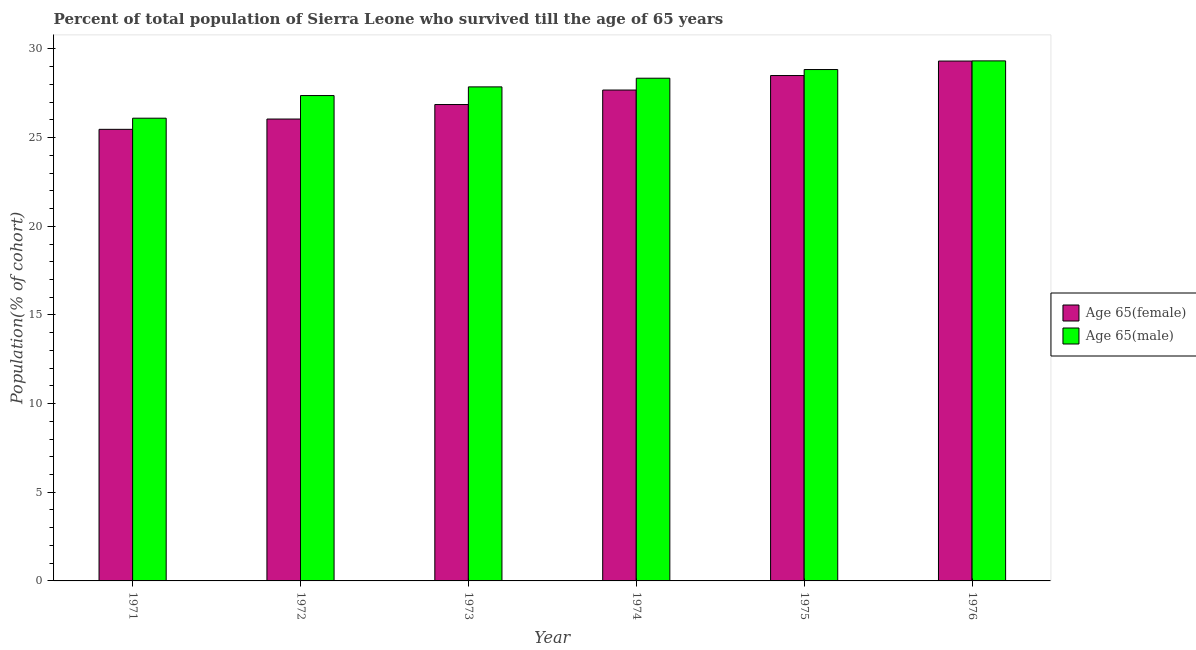Are the number of bars on each tick of the X-axis equal?
Keep it short and to the point. Yes. How many bars are there on the 6th tick from the left?
Provide a succinct answer. 2. What is the label of the 3rd group of bars from the left?
Make the answer very short. 1973. In how many cases, is the number of bars for a given year not equal to the number of legend labels?
Your answer should be very brief. 0. What is the percentage of male population who survived till age of 65 in 1976?
Make the answer very short. 29.33. Across all years, what is the maximum percentage of female population who survived till age of 65?
Ensure brevity in your answer.  29.32. Across all years, what is the minimum percentage of male population who survived till age of 65?
Ensure brevity in your answer.  26.09. In which year was the percentage of female population who survived till age of 65 maximum?
Offer a very short reply. 1976. What is the total percentage of female population who survived till age of 65 in the graph?
Ensure brevity in your answer.  163.88. What is the difference between the percentage of male population who survived till age of 65 in 1972 and that in 1976?
Give a very brief answer. -1.96. What is the difference between the percentage of female population who survived till age of 65 in 1976 and the percentage of male population who survived till age of 65 in 1971?
Keep it short and to the point. 3.85. What is the average percentage of male population who survived till age of 65 per year?
Give a very brief answer. 27.97. In the year 1971, what is the difference between the percentage of male population who survived till age of 65 and percentage of female population who survived till age of 65?
Provide a succinct answer. 0. What is the ratio of the percentage of female population who survived till age of 65 in 1972 to that in 1973?
Provide a succinct answer. 0.97. Is the percentage of female population who survived till age of 65 in 1973 less than that in 1975?
Provide a succinct answer. Yes. What is the difference between the highest and the second highest percentage of male population who survived till age of 65?
Your answer should be compact. 0.49. What is the difference between the highest and the lowest percentage of female population who survived till age of 65?
Make the answer very short. 3.85. In how many years, is the percentage of female population who survived till age of 65 greater than the average percentage of female population who survived till age of 65 taken over all years?
Your answer should be compact. 3. What does the 1st bar from the left in 1971 represents?
Provide a succinct answer. Age 65(female). What does the 2nd bar from the right in 1971 represents?
Offer a terse response. Age 65(female). How many years are there in the graph?
Provide a succinct answer. 6. What is the difference between two consecutive major ticks on the Y-axis?
Offer a very short reply. 5. Are the values on the major ticks of Y-axis written in scientific E-notation?
Your answer should be very brief. No. Does the graph contain grids?
Offer a terse response. No. How are the legend labels stacked?
Give a very brief answer. Vertical. What is the title of the graph?
Give a very brief answer. Percent of total population of Sierra Leone who survived till the age of 65 years. What is the label or title of the X-axis?
Provide a short and direct response. Year. What is the label or title of the Y-axis?
Keep it short and to the point. Population(% of cohort). What is the Population(% of cohort) of Age 65(female) in 1971?
Your response must be concise. 25.47. What is the Population(% of cohort) in Age 65(male) in 1971?
Offer a very short reply. 26.09. What is the Population(% of cohort) of Age 65(female) in 1972?
Your answer should be compact. 26.05. What is the Population(% of cohort) of Age 65(male) in 1972?
Your answer should be compact. 27.37. What is the Population(% of cohort) of Age 65(female) in 1973?
Ensure brevity in your answer.  26.86. What is the Population(% of cohort) in Age 65(male) in 1973?
Offer a terse response. 27.86. What is the Population(% of cohort) of Age 65(female) in 1974?
Your response must be concise. 27.68. What is the Population(% of cohort) in Age 65(male) in 1974?
Ensure brevity in your answer.  28.35. What is the Population(% of cohort) of Age 65(female) in 1975?
Make the answer very short. 28.5. What is the Population(% of cohort) in Age 65(male) in 1975?
Make the answer very short. 28.84. What is the Population(% of cohort) in Age 65(female) in 1976?
Your answer should be very brief. 29.32. What is the Population(% of cohort) of Age 65(male) in 1976?
Offer a very short reply. 29.33. Across all years, what is the maximum Population(% of cohort) of Age 65(female)?
Give a very brief answer. 29.32. Across all years, what is the maximum Population(% of cohort) of Age 65(male)?
Provide a short and direct response. 29.33. Across all years, what is the minimum Population(% of cohort) of Age 65(female)?
Keep it short and to the point. 25.47. Across all years, what is the minimum Population(% of cohort) of Age 65(male)?
Make the answer very short. 26.09. What is the total Population(% of cohort) of Age 65(female) in the graph?
Provide a short and direct response. 163.88. What is the total Population(% of cohort) in Age 65(male) in the graph?
Offer a terse response. 167.84. What is the difference between the Population(% of cohort) of Age 65(female) in 1971 and that in 1972?
Your answer should be compact. -0.58. What is the difference between the Population(% of cohort) in Age 65(male) in 1971 and that in 1972?
Your response must be concise. -1.28. What is the difference between the Population(% of cohort) in Age 65(female) in 1971 and that in 1973?
Ensure brevity in your answer.  -1.4. What is the difference between the Population(% of cohort) of Age 65(male) in 1971 and that in 1973?
Make the answer very short. -1.77. What is the difference between the Population(% of cohort) in Age 65(female) in 1971 and that in 1974?
Offer a terse response. -2.22. What is the difference between the Population(% of cohort) of Age 65(male) in 1971 and that in 1974?
Ensure brevity in your answer.  -2.25. What is the difference between the Population(% of cohort) of Age 65(female) in 1971 and that in 1975?
Your response must be concise. -3.03. What is the difference between the Population(% of cohort) in Age 65(male) in 1971 and that in 1975?
Your response must be concise. -2.74. What is the difference between the Population(% of cohort) of Age 65(female) in 1971 and that in 1976?
Make the answer very short. -3.85. What is the difference between the Population(% of cohort) in Age 65(male) in 1971 and that in 1976?
Give a very brief answer. -3.23. What is the difference between the Population(% of cohort) in Age 65(female) in 1972 and that in 1973?
Your answer should be very brief. -0.82. What is the difference between the Population(% of cohort) in Age 65(male) in 1972 and that in 1973?
Give a very brief answer. -0.49. What is the difference between the Population(% of cohort) in Age 65(female) in 1972 and that in 1974?
Make the answer very short. -1.64. What is the difference between the Population(% of cohort) of Age 65(male) in 1972 and that in 1974?
Your answer should be very brief. -0.98. What is the difference between the Population(% of cohort) of Age 65(female) in 1972 and that in 1975?
Offer a very short reply. -2.45. What is the difference between the Population(% of cohort) in Age 65(male) in 1972 and that in 1975?
Your response must be concise. -1.47. What is the difference between the Population(% of cohort) in Age 65(female) in 1972 and that in 1976?
Your answer should be very brief. -3.27. What is the difference between the Population(% of cohort) of Age 65(male) in 1972 and that in 1976?
Your answer should be compact. -1.96. What is the difference between the Population(% of cohort) in Age 65(female) in 1973 and that in 1974?
Your answer should be compact. -0.82. What is the difference between the Population(% of cohort) in Age 65(male) in 1973 and that in 1974?
Give a very brief answer. -0.49. What is the difference between the Population(% of cohort) of Age 65(female) in 1973 and that in 1975?
Your answer should be very brief. -1.64. What is the difference between the Population(% of cohort) of Age 65(male) in 1973 and that in 1975?
Offer a terse response. -0.98. What is the difference between the Population(% of cohort) in Age 65(female) in 1973 and that in 1976?
Keep it short and to the point. -2.45. What is the difference between the Population(% of cohort) of Age 65(male) in 1973 and that in 1976?
Make the answer very short. -1.47. What is the difference between the Population(% of cohort) in Age 65(female) in 1974 and that in 1975?
Your answer should be compact. -0.82. What is the difference between the Population(% of cohort) in Age 65(male) in 1974 and that in 1975?
Make the answer very short. -0.49. What is the difference between the Population(% of cohort) in Age 65(female) in 1974 and that in 1976?
Your answer should be compact. -1.64. What is the difference between the Population(% of cohort) in Age 65(male) in 1974 and that in 1976?
Offer a terse response. -0.98. What is the difference between the Population(% of cohort) of Age 65(female) in 1975 and that in 1976?
Provide a succinct answer. -0.82. What is the difference between the Population(% of cohort) in Age 65(male) in 1975 and that in 1976?
Your answer should be compact. -0.49. What is the difference between the Population(% of cohort) in Age 65(female) in 1971 and the Population(% of cohort) in Age 65(male) in 1972?
Offer a very short reply. -1.9. What is the difference between the Population(% of cohort) in Age 65(female) in 1971 and the Population(% of cohort) in Age 65(male) in 1973?
Provide a succinct answer. -2.39. What is the difference between the Population(% of cohort) in Age 65(female) in 1971 and the Population(% of cohort) in Age 65(male) in 1974?
Your answer should be compact. -2.88. What is the difference between the Population(% of cohort) in Age 65(female) in 1971 and the Population(% of cohort) in Age 65(male) in 1975?
Provide a succinct answer. -3.37. What is the difference between the Population(% of cohort) of Age 65(female) in 1971 and the Population(% of cohort) of Age 65(male) in 1976?
Make the answer very short. -3.86. What is the difference between the Population(% of cohort) in Age 65(female) in 1972 and the Population(% of cohort) in Age 65(male) in 1973?
Ensure brevity in your answer.  -1.81. What is the difference between the Population(% of cohort) of Age 65(female) in 1972 and the Population(% of cohort) of Age 65(male) in 1974?
Provide a succinct answer. -2.3. What is the difference between the Population(% of cohort) of Age 65(female) in 1972 and the Population(% of cohort) of Age 65(male) in 1975?
Give a very brief answer. -2.79. What is the difference between the Population(% of cohort) of Age 65(female) in 1972 and the Population(% of cohort) of Age 65(male) in 1976?
Offer a terse response. -3.28. What is the difference between the Population(% of cohort) in Age 65(female) in 1973 and the Population(% of cohort) in Age 65(male) in 1974?
Provide a succinct answer. -1.48. What is the difference between the Population(% of cohort) of Age 65(female) in 1973 and the Population(% of cohort) of Age 65(male) in 1975?
Provide a short and direct response. -1.97. What is the difference between the Population(% of cohort) in Age 65(female) in 1973 and the Population(% of cohort) in Age 65(male) in 1976?
Provide a succinct answer. -2.46. What is the difference between the Population(% of cohort) in Age 65(female) in 1974 and the Population(% of cohort) in Age 65(male) in 1975?
Make the answer very short. -1.16. What is the difference between the Population(% of cohort) in Age 65(female) in 1974 and the Population(% of cohort) in Age 65(male) in 1976?
Provide a succinct answer. -1.64. What is the difference between the Population(% of cohort) of Age 65(female) in 1975 and the Population(% of cohort) of Age 65(male) in 1976?
Offer a terse response. -0.83. What is the average Population(% of cohort) of Age 65(female) per year?
Your answer should be compact. 27.31. What is the average Population(% of cohort) of Age 65(male) per year?
Your answer should be compact. 27.97. In the year 1971, what is the difference between the Population(% of cohort) in Age 65(female) and Population(% of cohort) in Age 65(male)?
Your answer should be compact. -0.63. In the year 1972, what is the difference between the Population(% of cohort) of Age 65(female) and Population(% of cohort) of Age 65(male)?
Your answer should be compact. -1.32. In the year 1973, what is the difference between the Population(% of cohort) of Age 65(female) and Population(% of cohort) of Age 65(male)?
Make the answer very short. -1. In the year 1974, what is the difference between the Population(% of cohort) of Age 65(female) and Population(% of cohort) of Age 65(male)?
Keep it short and to the point. -0.67. In the year 1975, what is the difference between the Population(% of cohort) in Age 65(female) and Population(% of cohort) in Age 65(male)?
Keep it short and to the point. -0.34. In the year 1976, what is the difference between the Population(% of cohort) in Age 65(female) and Population(% of cohort) in Age 65(male)?
Keep it short and to the point. -0.01. What is the ratio of the Population(% of cohort) in Age 65(female) in 1971 to that in 1972?
Offer a very short reply. 0.98. What is the ratio of the Population(% of cohort) in Age 65(male) in 1971 to that in 1972?
Ensure brevity in your answer.  0.95. What is the ratio of the Population(% of cohort) of Age 65(female) in 1971 to that in 1973?
Offer a very short reply. 0.95. What is the ratio of the Population(% of cohort) of Age 65(male) in 1971 to that in 1973?
Provide a short and direct response. 0.94. What is the ratio of the Population(% of cohort) in Age 65(male) in 1971 to that in 1974?
Provide a short and direct response. 0.92. What is the ratio of the Population(% of cohort) in Age 65(female) in 1971 to that in 1975?
Make the answer very short. 0.89. What is the ratio of the Population(% of cohort) in Age 65(male) in 1971 to that in 1975?
Your answer should be very brief. 0.9. What is the ratio of the Population(% of cohort) of Age 65(female) in 1971 to that in 1976?
Provide a short and direct response. 0.87. What is the ratio of the Population(% of cohort) of Age 65(male) in 1971 to that in 1976?
Ensure brevity in your answer.  0.89. What is the ratio of the Population(% of cohort) in Age 65(female) in 1972 to that in 1973?
Make the answer very short. 0.97. What is the ratio of the Population(% of cohort) in Age 65(male) in 1972 to that in 1973?
Make the answer very short. 0.98. What is the ratio of the Population(% of cohort) of Age 65(female) in 1972 to that in 1974?
Provide a short and direct response. 0.94. What is the ratio of the Population(% of cohort) of Age 65(male) in 1972 to that in 1974?
Offer a very short reply. 0.97. What is the ratio of the Population(% of cohort) in Age 65(female) in 1972 to that in 1975?
Provide a short and direct response. 0.91. What is the ratio of the Population(% of cohort) in Age 65(male) in 1972 to that in 1975?
Your answer should be compact. 0.95. What is the ratio of the Population(% of cohort) of Age 65(female) in 1972 to that in 1976?
Give a very brief answer. 0.89. What is the ratio of the Population(% of cohort) of Age 65(male) in 1972 to that in 1976?
Give a very brief answer. 0.93. What is the ratio of the Population(% of cohort) in Age 65(female) in 1973 to that in 1974?
Your answer should be very brief. 0.97. What is the ratio of the Population(% of cohort) in Age 65(male) in 1973 to that in 1974?
Your response must be concise. 0.98. What is the ratio of the Population(% of cohort) of Age 65(female) in 1973 to that in 1975?
Your answer should be very brief. 0.94. What is the ratio of the Population(% of cohort) of Age 65(male) in 1973 to that in 1975?
Keep it short and to the point. 0.97. What is the ratio of the Population(% of cohort) in Age 65(female) in 1973 to that in 1976?
Provide a succinct answer. 0.92. What is the ratio of the Population(% of cohort) of Age 65(female) in 1974 to that in 1975?
Your answer should be very brief. 0.97. What is the ratio of the Population(% of cohort) in Age 65(male) in 1974 to that in 1975?
Offer a terse response. 0.98. What is the ratio of the Population(% of cohort) in Age 65(female) in 1974 to that in 1976?
Offer a very short reply. 0.94. What is the ratio of the Population(% of cohort) in Age 65(male) in 1974 to that in 1976?
Keep it short and to the point. 0.97. What is the ratio of the Population(% of cohort) of Age 65(female) in 1975 to that in 1976?
Provide a short and direct response. 0.97. What is the ratio of the Population(% of cohort) of Age 65(male) in 1975 to that in 1976?
Provide a succinct answer. 0.98. What is the difference between the highest and the second highest Population(% of cohort) of Age 65(female)?
Your answer should be compact. 0.82. What is the difference between the highest and the second highest Population(% of cohort) of Age 65(male)?
Offer a very short reply. 0.49. What is the difference between the highest and the lowest Population(% of cohort) in Age 65(female)?
Offer a very short reply. 3.85. What is the difference between the highest and the lowest Population(% of cohort) in Age 65(male)?
Ensure brevity in your answer.  3.23. 